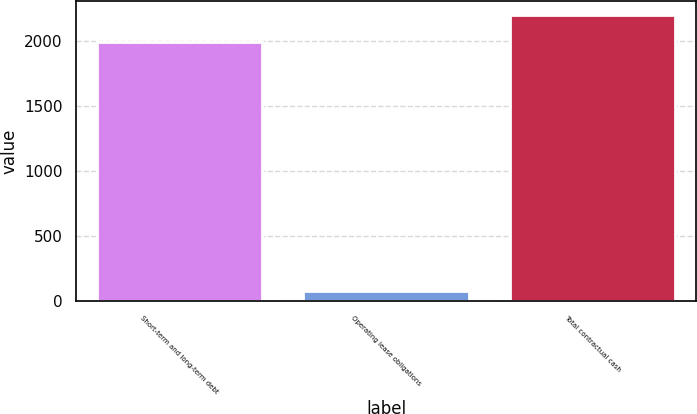Convert chart to OTSL. <chart><loc_0><loc_0><loc_500><loc_500><bar_chart><fcel>Short-term and long-term debt<fcel>Operating lease obligations<fcel>Total contractual cash<nl><fcel>1993<fcel>78<fcel>2202.4<nl></chart> 